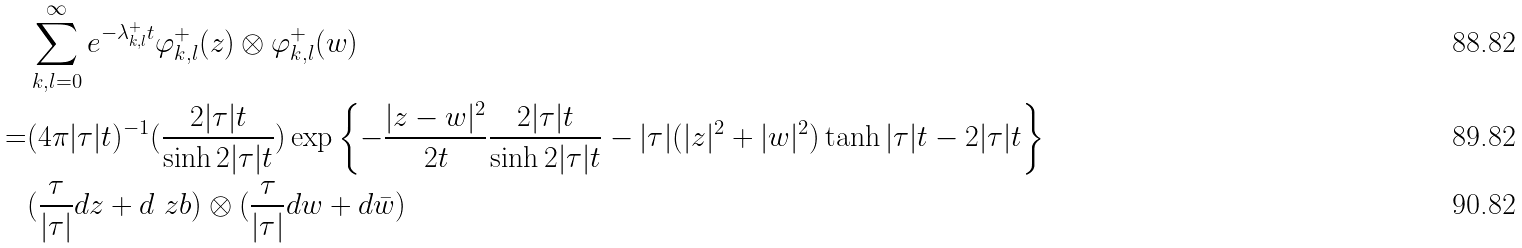<formula> <loc_0><loc_0><loc_500><loc_500>& \sum _ { k , l = 0 } ^ { \infty } e ^ { - \lambda _ { k , l } ^ { + } t } \varphi _ { k , l } ^ { + } ( z ) \otimes \varphi _ { k , l } ^ { + } ( w ) \\ = & ( 4 \pi | \tau | t ) ^ { - 1 } ( \frac { 2 | \tau | t } { \sinh 2 | \tau | t } ) \exp \left \{ { - \frac { | z - w | ^ { 2 } } { 2 t } \frac { 2 | \tau | t } { \sinh 2 | \tau | t } - | \tau | ( | z | ^ { 2 } + | w | ^ { 2 } ) \tanh | \tau | t - 2 | \tau | t } \right \} \\ & ( \frac { \tau } { | \tau | } d z + d \ z b ) \otimes ( \frac { \tau } { | \tau | } d w + d \bar { w } )</formula> 